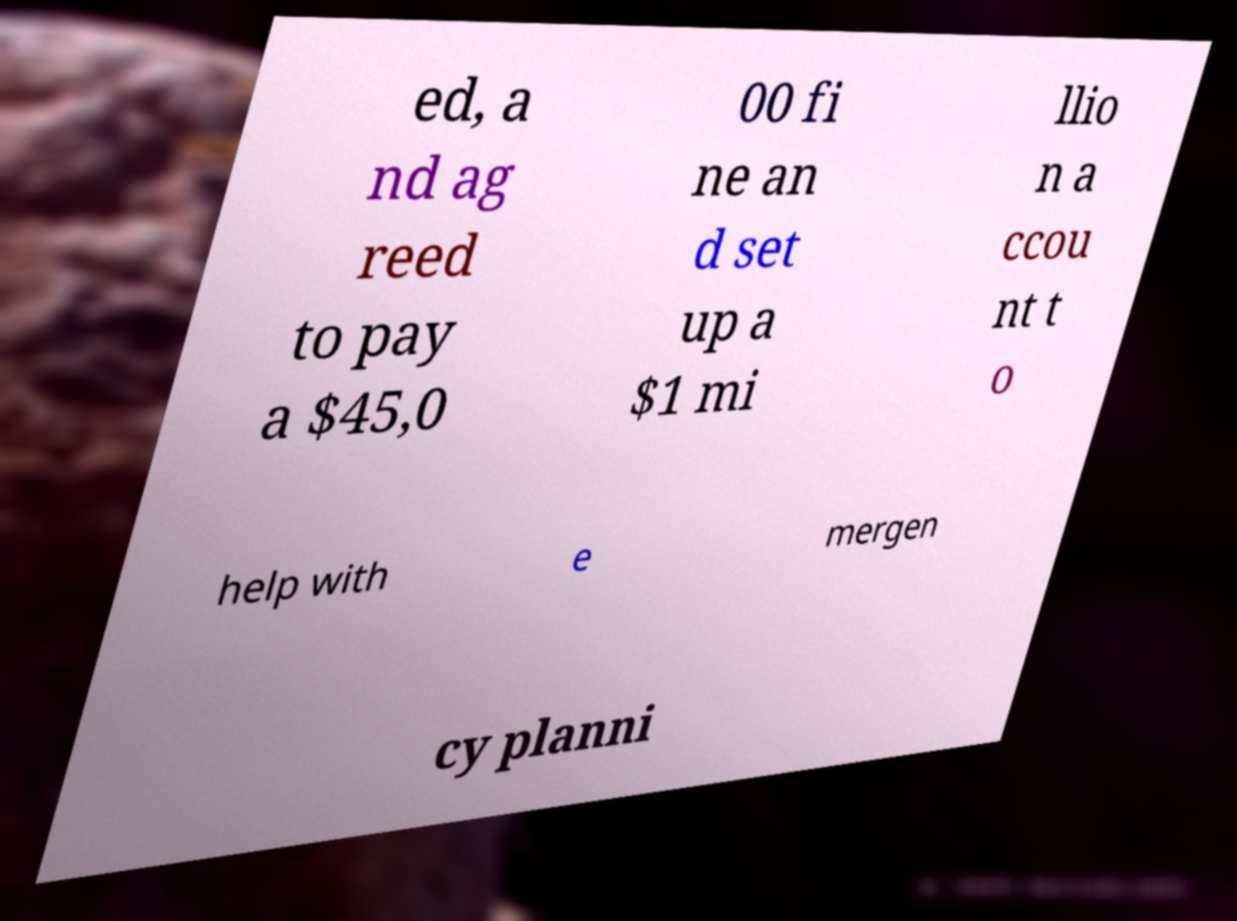For documentation purposes, I need the text within this image transcribed. Could you provide that? ed, a nd ag reed to pay a $45,0 00 fi ne an d set up a $1 mi llio n a ccou nt t o help with e mergen cy planni 